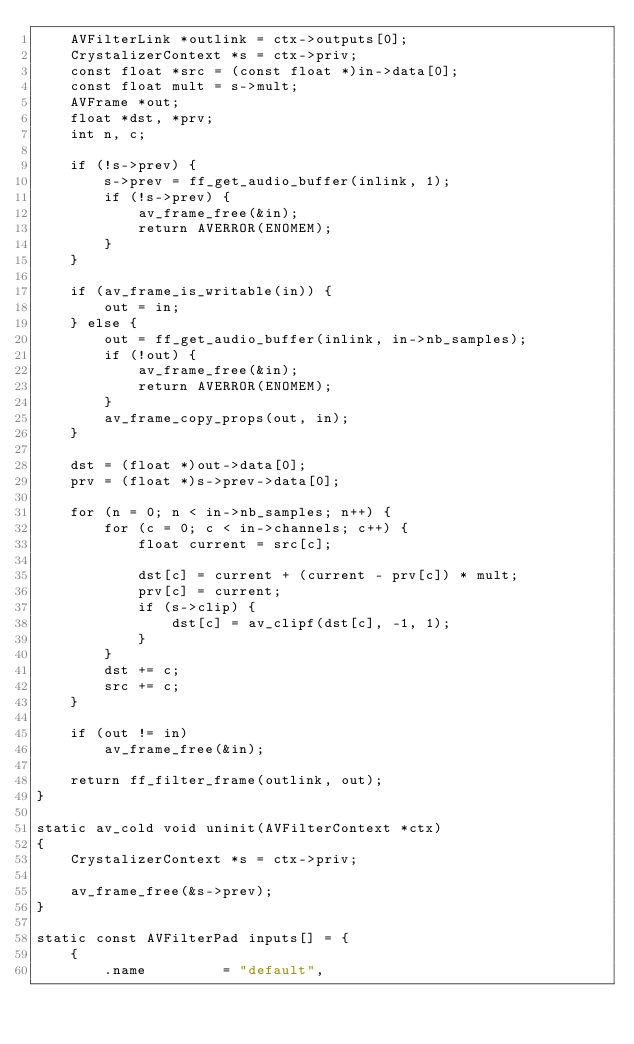<code> <loc_0><loc_0><loc_500><loc_500><_C_>    AVFilterLink *outlink = ctx->outputs[0];
    CrystalizerContext *s = ctx->priv;
    const float *src = (const float *)in->data[0];
    const float mult = s->mult;
    AVFrame *out;
    float *dst, *prv;
    int n, c;

    if (!s->prev) {
        s->prev = ff_get_audio_buffer(inlink, 1);
        if (!s->prev) {
            av_frame_free(&in);
            return AVERROR(ENOMEM);
        }
    }

    if (av_frame_is_writable(in)) {
        out = in;
    } else {
        out = ff_get_audio_buffer(inlink, in->nb_samples);
        if (!out) {
            av_frame_free(&in);
            return AVERROR(ENOMEM);
        }
        av_frame_copy_props(out, in);
    }

    dst = (float *)out->data[0];
    prv = (float *)s->prev->data[0];

    for (n = 0; n < in->nb_samples; n++) {
        for (c = 0; c < in->channels; c++) {
            float current = src[c];

            dst[c] = current + (current - prv[c]) * mult;
            prv[c] = current;
            if (s->clip) {
                dst[c] = av_clipf(dst[c], -1, 1);
            }
        }
        dst += c;
        src += c;
    }

    if (out != in)
        av_frame_free(&in);

    return ff_filter_frame(outlink, out);
}

static av_cold void uninit(AVFilterContext *ctx)
{
    CrystalizerContext *s = ctx->priv;

    av_frame_free(&s->prev);
}

static const AVFilterPad inputs[] = {
    {
        .name         = "default",</code> 